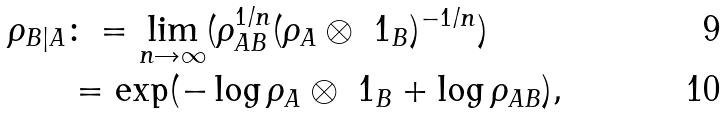<formula> <loc_0><loc_0><loc_500><loc_500>\rho _ { B | A } & \colon = \lim _ { n \rightarrow \infty } ( \rho _ { A B } ^ { 1 / n } ( \rho _ { A } \otimes \ 1 _ { B } ) ^ { - 1 / n } ) \\ & = \exp ( - \log \rho _ { A } \otimes \ 1 _ { B } + \log \rho _ { A B } ) ,</formula> 